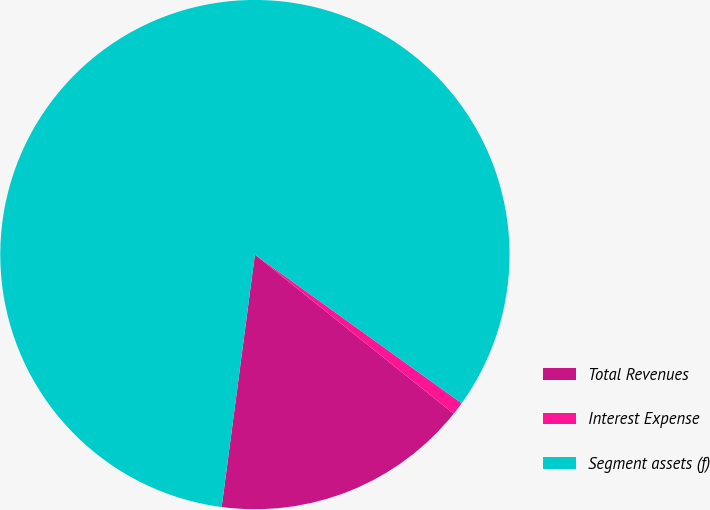Convert chart to OTSL. <chart><loc_0><loc_0><loc_500><loc_500><pie_chart><fcel>Total Revenues<fcel>Interest Expense<fcel>Segment assets (f)<nl><fcel>16.34%<fcel>0.82%<fcel>82.84%<nl></chart> 